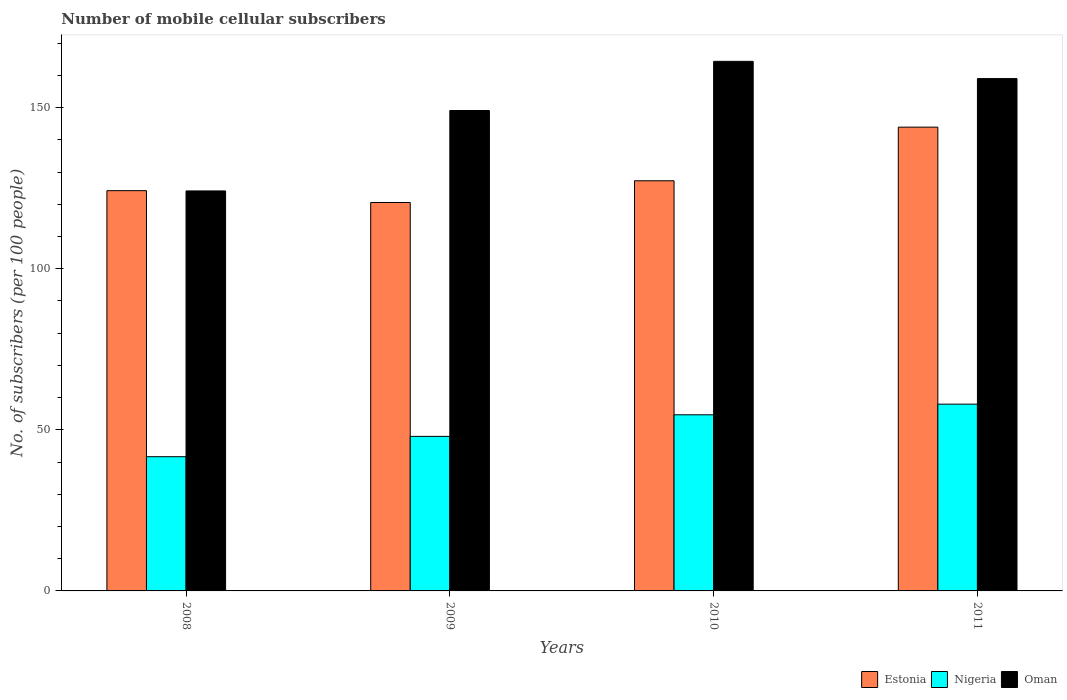Are the number of bars per tick equal to the number of legend labels?
Your answer should be compact. Yes. How many bars are there on the 2nd tick from the left?
Offer a terse response. 3. In how many cases, is the number of bars for a given year not equal to the number of legend labels?
Provide a short and direct response. 0. What is the number of mobile cellular subscribers in Oman in 2011?
Offer a terse response. 159. Across all years, what is the maximum number of mobile cellular subscribers in Oman?
Offer a terse response. 164.34. Across all years, what is the minimum number of mobile cellular subscribers in Estonia?
Offer a very short reply. 120.54. In which year was the number of mobile cellular subscribers in Estonia minimum?
Keep it short and to the point. 2009. What is the total number of mobile cellular subscribers in Nigeria in the graph?
Provide a short and direct response. 202.24. What is the difference between the number of mobile cellular subscribers in Oman in 2009 and that in 2011?
Your answer should be very brief. -9.91. What is the difference between the number of mobile cellular subscribers in Estonia in 2008 and the number of mobile cellular subscribers in Nigeria in 2009?
Make the answer very short. 76.25. What is the average number of mobile cellular subscribers in Estonia per year?
Keep it short and to the point. 128.99. In the year 2009, what is the difference between the number of mobile cellular subscribers in Estonia and number of mobile cellular subscribers in Nigeria?
Give a very brief answer. 72.58. In how many years, is the number of mobile cellular subscribers in Nigeria greater than 40?
Your answer should be very brief. 4. What is the ratio of the number of mobile cellular subscribers in Nigeria in 2010 to that in 2011?
Provide a succinct answer. 0.94. Is the difference between the number of mobile cellular subscribers in Estonia in 2008 and 2010 greater than the difference between the number of mobile cellular subscribers in Nigeria in 2008 and 2010?
Keep it short and to the point. Yes. What is the difference between the highest and the second highest number of mobile cellular subscribers in Estonia?
Provide a succinct answer. 16.64. What is the difference between the highest and the lowest number of mobile cellular subscribers in Estonia?
Give a very brief answer. 23.39. What does the 1st bar from the left in 2011 represents?
Keep it short and to the point. Estonia. What does the 1st bar from the right in 2010 represents?
Keep it short and to the point. Oman. How many years are there in the graph?
Your answer should be compact. 4. Does the graph contain grids?
Keep it short and to the point. No. Where does the legend appear in the graph?
Offer a terse response. Bottom right. How many legend labels are there?
Offer a very short reply. 3. What is the title of the graph?
Give a very brief answer. Number of mobile cellular subscribers. What is the label or title of the Y-axis?
Make the answer very short. No. of subscribers (per 100 people). What is the No. of subscribers (per 100 people) in Estonia in 2008?
Provide a short and direct response. 124.21. What is the No. of subscribers (per 100 people) in Nigeria in 2008?
Provide a short and direct response. 41.66. What is the No. of subscribers (per 100 people) in Oman in 2008?
Make the answer very short. 124.13. What is the No. of subscribers (per 100 people) of Estonia in 2009?
Provide a succinct answer. 120.54. What is the No. of subscribers (per 100 people) of Nigeria in 2009?
Ensure brevity in your answer.  47.96. What is the No. of subscribers (per 100 people) of Oman in 2009?
Ensure brevity in your answer.  149.09. What is the No. of subscribers (per 100 people) of Estonia in 2010?
Make the answer very short. 127.28. What is the No. of subscribers (per 100 people) of Nigeria in 2010?
Offer a terse response. 54.66. What is the No. of subscribers (per 100 people) of Oman in 2010?
Provide a short and direct response. 164.34. What is the No. of subscribers (per 100 people) of Estonia in 2011?
Offer a terse response. 143.93. What is the No. of subscribers (per 100 people) of Nigeria in 2011?
Provide a short and direct response. 57.96. What is the No. of subscribers (per 100 people) of Oman in 2011?
Keep it short and to the point. 159. Across all years, what is the maximum No. of subscribers (per 100 people) of Estonia?
Make the answer very short. 143.93. Across all years, what is the maximum No. of subscribers (per 100 people) in Nigeria?
Make the answer very short. 57.96. Across all years, what is the maximum No. of subscribers (per 100 people) in Oman?
Give a very brief answer. 164.34. Across all years, what is the minimum No. of subscribers (per 100 people) in Estonia?
Keep it short and to the point. 120.54. Across all years, what is the minimum No. of subscribers (per 100 people) of Nigeria?
Your answer should be very brief. 41.66. Across all years, what is the minimum No. of subscribers (per 100 people) of Oman?
Make the answer very short. 124.13. What is the total No. of subscribers (per 100 people) of Estonia in the graph?
Ensure brevity in your answer.  515.96. What is the total No. of subscribers (per 100 people) of Nigeria in the graph?
Your response must be concise. 202.24. What is the total No. of subscribers (per 100 people) in Oman in the graph?
Your answer should be compact. 596.56. What is the difference between the No. of subscribers (per 100 people) of Estonia in 2008 and that in 2009?
Your answer should be compact. 3.68. What is the difference between the No. of subscribers (per 100 people) in Nigeria in 2008 and that in 2009?
Your answer should be compact. -6.3. What is the difference between the No. of subscribers (per 100 people) in Oman in 2008 and that in 2009?
Give a very brief answer. -24.96. What is the difference between the No. of subscribers (per 100 people) in Estonia in 2008 and that in 2010?
Your answer should be compact. -3.07. What is the difference between the No. of subscribers (per 100 people) of Nigeria in 2008 and that in 2010?
Provide a succinct answer. -13. What is the difference between the No. of subscribers (per 100 people) in Oman in 2008 and that in 2010?
Keep it short and to the point. -40.21. What is the difference between the No. of subscribers (per 100 people) in Estonia in 2008 and that in 2011?
Offer a terse response. -19.72. What is the difference between the No. of subscribers (per 100 people) of Nigeria in 2008 and that in 2011?
Ensure brevity in your answer.  -16.3. What is the difference between the No. of subscribers (per 100 people) of Oman in 2008 and that in 2011?
Offer a terse response. -34.86. What is the difference between the No. of subscribers (per 100 people) of Estonia in 2009 and that in 2010?
Your answer should be compact. -6.75. What is the difference between the No. of subscribers (per 100 people) in Nigeria in 2009 and that in 2010?
Offer a very short reply. -6.7. What is the difference between the No. of subscribers (per 100 people) of Oman in 2009 and that in 2010?
Offer a terse response. -15.25. What is the difference between the No. of subscribers (per 100 people) of Estonia in 2009 and that in 2011?
Keep it short and to the point. -23.39. What is the difference between the No. of subscribers (per 100 people) in Nigeria in 2009 and that in 2011?
Your response must be concise. -10. What is the difference between the No. of subscribers (per 100 people) of Oman in 2009 and that in 2011?
Your response must be concise. -9.91. What is the difference between the No. of subscribers (per 100 people) of Estonia in 2010 and that in 2011?
Ensure brevity in your answer.  -16.64. What is the difference between the No. of subscribers (per 100 people) in Nigeria in 2010 and that in 2011?
Give a very brief answer. -3.3. What is the difference between the No. of subscribers (per 100 people) in Oman in 2010 and that in 2011?
Ensure brevity in your answer.  5.35. What is the difference between the No. of subscribers (per 100 people) in Estonia in 2008 and the No. of subscribers (per 100 people) in Nigeria in 2009?
Give a very brief answer. 76.25. What is the difference between the No. of subscribers (per 100 people) in Estonia in 2008 and the No. of subscribers (per 100 people) in Oman in 2009?
Your response must be concise. -24.88. What is the difference between the No. of subscribers (per 100 people) of Nigeria in 2008 and the No. of subscribers (per 100 people) of Oman in 2009?
Your response must be concise. -107.43. What is the difference between the No. of subscribers (per 100 people) in Estonia in 2008 and the No. of subscribers (per 100 people) in Nigeria in 2010?
Your answer should be very brief. 69.55. What is the difference between the No. of subscribers (per 100 people) of Estonia in 2008 and the No. of subscribers (per 100 people) of Oman in 2010?
Offer a terse response. -40.13. What is the difference between the No. of subscribers (per 100 people) of Nigeria in 2008 and the No. of subscribers (per 100 people) of Oman in 2010?
Offer a very short reply. -122.69. What is the difference between the No. of subscribers (per 100 people) in Estonia in 2008 and the No. of subscribers (per 100 people) in Nigeria in 2011?
Ensure brevity in your answer.  66.25. What is the difference between the No. of subscribers (per 100 people) in Estonia in 2008 and the No. of subscribers (per 100 people) in Oman in 2011?
Your response must be concise. -34.78. What is the difference between the No. of subscribers (per 100 people) in Nigeria in 2008 and the No. of subscribers (per 100 people) in Oman in 2011?
Give a very brief answer. -117.34. What is the difference between the No. of subscribers (per 100 people) of Estonia in 2009 and the No. of subscribers (per 100 people) of Nigeria in 2010?
Offer a very short reply. 65.87. What is the difference between the No. of subscribers (per 100 people) in Estonia in 2009 and the No. of subscribers (per 100 people) in Oman in 2010?
Ensure brevity in your answer.  -43.81. What is the difference between the No. of subscribers (per 100 people) in Nigeria in 2009 and the No. of subscribers (per 100 people) in Oman in 2010?
Your answer should be very brief. -116.38. What is the difference between the No. of subscribers (per 100 people) in Estonia in 2009 and the No. of subscribers (per 100 people) in Nigeria in 2011?
Keep it short and to the point. 62.58. What is the difference between the No. of subscribers (per 100 people) of Estonia in 2009 and the No. of subscribers (per 100 people) of Oman in 2011?
Provide a succinct answer. -38.46. What is the difference between the No. of subscribers (per 100 people) in Nigeria in 2009 and the No. of subscribers (per 100 people) in Oman in 2011?
Offer a terse response. -111.04. What is the difference between the No. of subscribers (per 100 people) of Estonia in 2010 and the No. of subscribers (per 100 people) of Nigeria in 2011?
Your answer should be very brief. 69.32. What is the difference between the No. of subscribers (per 100 people) in Estonia in 2010 and the No. of subscribers (per 100 people) in Oman in 2011?
Your answer should be compact. -31.71. What is the difference between the No. of subscribers (per 100 people) in Nigeria in 2010 and the No. of subscribers (per 100 people) in Oman in 2011?
Your answer should be compact. -104.33. What is the average No. of subscribers (per 100 people) in Estonia per year?
Give a very brief answer. 128.99. What is the average No. of subscribers (per 100 people) of Nigeria per year?
Provide a short and direct response. 50.56. What is the average No. of subscribers (per 100 people) of Oman per year?
Keep it short and to the point. 149.14. In the year 2008, what is the difference between the No. of subscribers (per 100 people) in Estonia and No. of subscribers (per 100 people) in Nigeria?
Offer a terse response. 82.55. In the year 2008, what is the difference between the No. of subscribers (per 100 people) in Estonia and No. of subscribers (per 100 people) in Oman?
Your answer should be very brief. 0.08. In the year 2008, what is the difference between the No. of subscribers (per 100 people) in Nigeria and No. of subscribers (per 100 people) in Oman?
Give a very brief answer. -82.47. In the year 2009, what is the difference between the No. of subscribers (per 100 people) in Estonia and No. of subscribers (per 100 people) in Nigeria?
Provide a short and direct response. 72.58. In the year 2009, what is the difference between the No. of subscribers (per 100 people) of Estonia and No. of subscribers (per 100 people) of Oman?
Provide a short and direct response. -28.55. In the year 2009, what is the difference between the No. of subscribers (per 100 people) in Nigeria and No. of subscribers (per 100 people) in Oman?
Keep it short and to the point. -101.13. In the year 2010, what is the difference between the No. of subscribers (per 100 people) in Estonia and No. of subscribers (per 100 people) in Nigeria?
Your response must be concise. 72.62. In the year 2010, what is the difference between the No. of subscribers (per 100 people) in Estonia and No. of subscribers (per 100 people) in Oman?
Your response must be concise. -37.06. In the year 2010, what is the difference between the No. of subscribers (per 100 people) of Nigeria and No. of subscribers (per 100 people) of Oman?
Your response must be concise. -109.68. In the year 2011, what is the difference between the No. of subscribers (per 100 people) in Estonia and No. of subscribers (per 100 people) in Nigeria?
Offer a very short reply. 85.97. In the year 2011, what is the difference between the No. of subscribers (per 100 people) in Estonia and No. of subscribers (per 100 people) in Oman?
Offer a terse response. -15.07. In the year 2011, what is the difference between the No. of subscribers (per 100 people) of Nigeria and No. of subscribers (per 100 people) of Oman?
Your answer should be very brief. -101.03. What is the ratio of the No. of subscribers (per 100 people) of Estonia in 2008 to that in 2009?
Your answer should be very brief. 1.03. What is the ratio of the No. of subscribers (per 100 people) of Nigeria in 2008 to that in 2009?
Make the answer very short. 0.87. What is the ratio of the No. of subscribers (per 100 people) of Oman in 2008 to that in 2009?
Your answer should be compact. 0.83. What is the ratio of the No. of subscribers (per 100 people) of Estonia in 2008 to that in 2010?
Ensure brevity in your answer.  0.98. What is the ratio of the No. of subscribers (per 100 people) of Nigeria in 2008 to that in 2010?
Give a very brief answer. 0.76. What is the ratio of the No. of subscribers (per 100 people) in Oman in 2008 to that in 2010?
Provide a short and direct response. 0.76. What is the ratio of the No. of subscribers (per 100 people) in Estonia in 2008 to that in 2011?
Offer a terse response. 0.86. What is the ratio of the No. of subscribers (per 100 people) in Nigeria in 2008 to that in 2011?
Provide a succinct answer. 0.72. What is the ratio of the No. of subscribers (per 100 people) in Oman in 2008 to that in 2011?
Make the answer very short. 0.78. What is the ratio of the No. of subscribers (per 100 people) in Estonia in 2009 to that in 2010?
Offer a terse response. 0.95. What is the ratio of the No. of subscribers (per 100 people) in Nigeria in 2009 to that in 2010?
Your response must be concise. 0.88. What is the ratio of the No. of subscribers (per 100 people) of Oman in 2009 to that in 2010?
Give a very brief answer. 0.91. What is the ratio of the No. of subscribers (per 100 people) in Estonia in 2009 to that in 2011?
Provide a succinct answer. 0.84. What is the ratio of the No. of subscribers (per 100 people) of Nigeria in 2009 to that in 2011?
Offer a very short reply. 0.83. What is the ratio of the No. of subscribers (per 100 people) of Oman in 2009 to that in 2011?
Provide a succinct answer. 0.94. What is the ratio of the No. of subscribers (per 100 people) in Estonia in 2010 to that in 2011?
Make the answer very short. 0.88. What is the ratio of the No. of subscribers (per 100 people) in Nigeria in 2010 to that in 2011?
Your answer should be compact. 0.94. What is the ratio of the No. of subscribers (per 100 people) of Oman in 2010 to that in 2011?
Your answer should be compact. 1.03. What is the difference between the highest and the second highest No. of subscribers (per 100 people) in Estonia?
Your answer should be very brief. 16.64. What is the difference between the highest and the second highest No. of subscribers (per 100 people) of Nigeria?
Your answer should be very brief. 3.3. What is the difference between the highest and the second highest No. of subscribers (per 100 people) of Oman?
Ensure brevity in your answer.  5.35. What is the difference between the highest and the lowest No. of subscribers (per 100 people) of Estonia?
Your answer should be very brief. 23.39. What is the difference between the highest and the lowest No. of subscribers (per 100 people) in Nigeria?
Give a very brief answer. 16.3. What is the difference between the highest and the lowest No. of subscribers (per 100 people) in Oman?
Your answer should be compact. 40.21. 